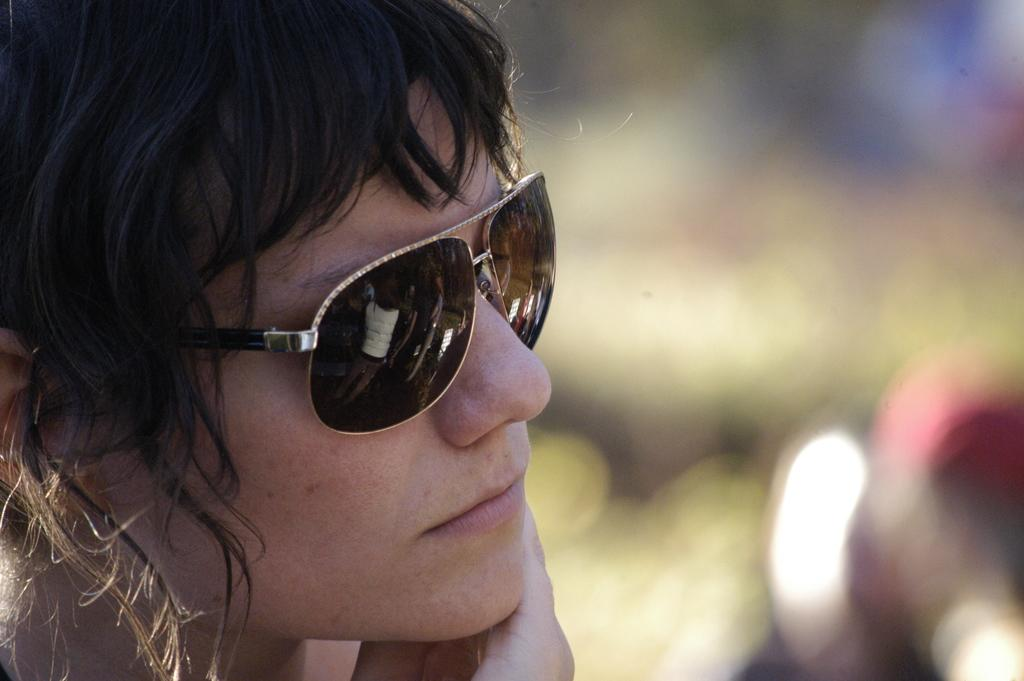Who is present in the image? There is a woman in the image. What is the woman wearing on her face? The woman is wearing goggles. Can you describe the background of the image? The background of the image is blurred. What type of string is the chicken using to tie its hair in the image? There is no chicken or hair present in the image, so it is not possible to determine what type of string might be used. 